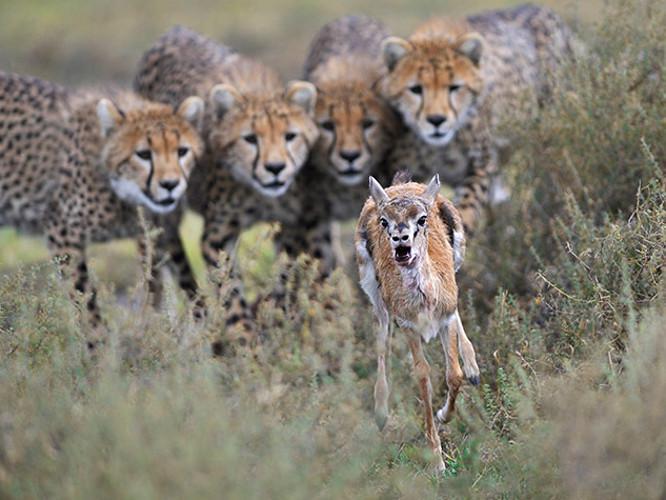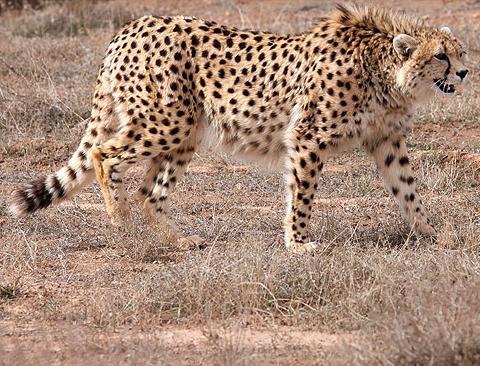The first image is the image on the left, the second image is the image on the right. Evaluate the accuracy of this statement regarding the images: "There is at least one cheetah atop a grassy mound". Is it true? Answer yes or no. No. The first image is the image on the left, the second image is the image on the right. Analyze the images presented: Is the assertion "At least one cheetah is laying on a mound." valid? Answer yes or no. No. 